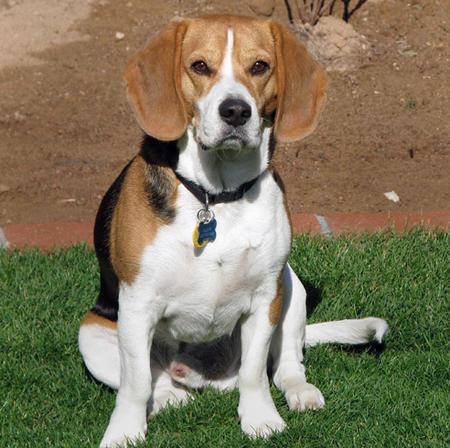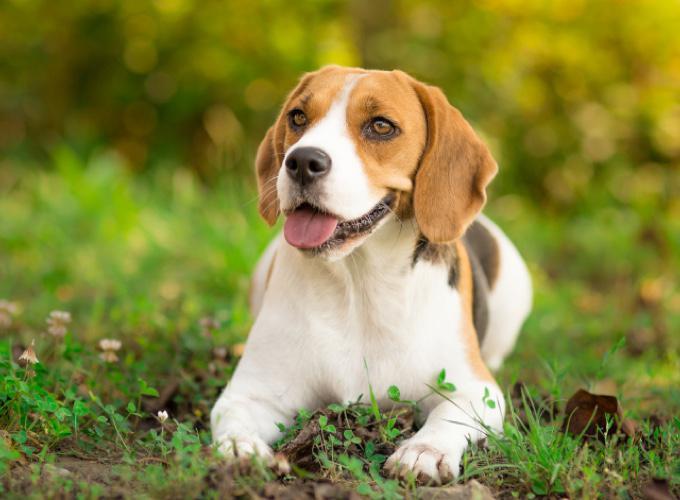The first image is the image on the left, the second image is the image on the right. Evaluate the accuracy of this statement regarding the images: "a beagle sitting in the grass has dog tags on it's collar". Is it true? Answer yes or no. Yes. 